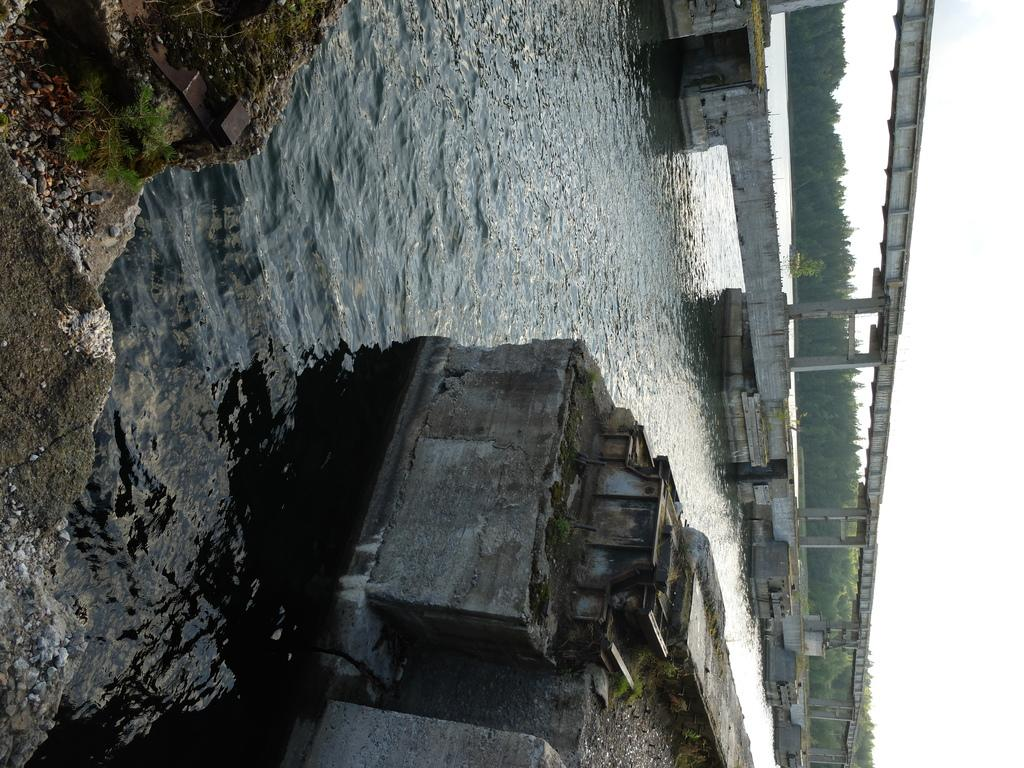What type of natural feature can be seen in the image? There is a river in the image. What structure is located on the right side of the image? There is a bridge on the right side of the image. What type of vegetation is present in the image? There are trees in the image. What is visible in the background of the image? The sky is visible in the background of the image. How many hens are sitting on the bridge in the image? There are no hens present in the image; it features a river, a bridge, trees, and the sky. What type of lock is used to secure the bridge in the image? There is no lock visible in the image, as the bridge appears to be a standard, open structure. 